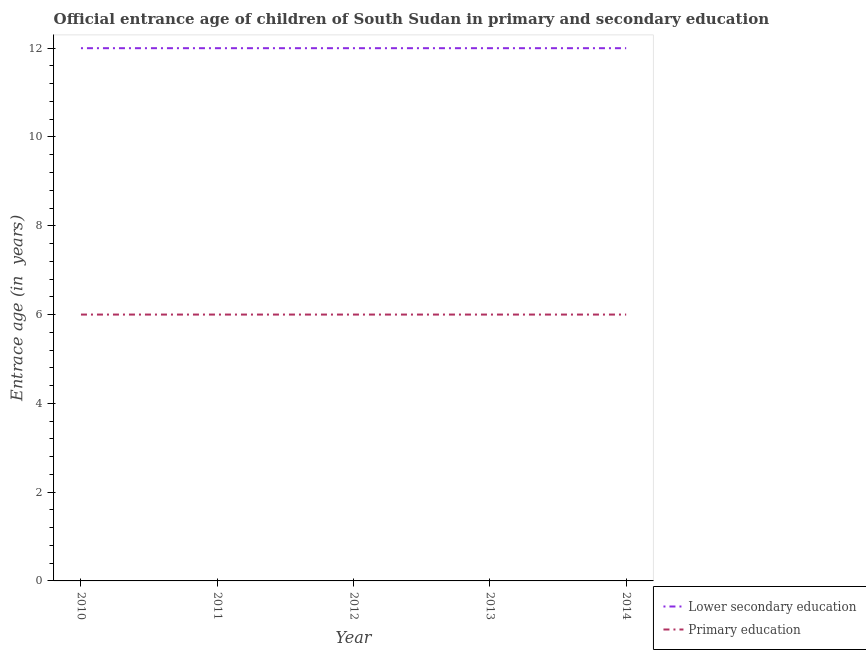Does the line corresponding to entrance age of children in lower secondary education intersect with the line corresponding to entrance age of chiildren in primary education?
Keep it short and to the point. No. Is the number of lines equal to the number of legend labels?
Offer a very short reply. Yes. What is the entrance age of chiildren in primary education in 2014?
Provide a short and direct response. 6. In which year was the entrance age of chiildren in primary education maximum?
Provide a short and direct response. 2010. What is the total entrance age of children in lower secondary education in the graph?
Keep it short and to the point. 60. What is the average entrance age of chiildren in primary education per year?
Keep it short and to the point. 6. In the year 2013, what is the difference between the entrance age of chiildren in primary education and entrance age of children in lower secondary education?
Give a very brief answer. -6. What is the ratio of the entrance age of children in lower secondary education in 2012 to that in 2013?
Offer a terse response. 1. Is the difference between the entrance age of chiildren in primary education in 2011 and 2013 greater than the difference between the entrance age of children in lower secondary education in 2011 and 2013?
Offer a very short reply. No. What is the difference between the highest and the second highest entrance age of chiildren in primary education?
Your answer should be compact. 0. In how many years, is the entrance age of children in lower secondary education greater than the average entrance age of children in lower secondary education taken over all years?
Provide a short and direct response. 0. Is the sum of the entrance age of chiildren in primary education in 2011 and 2012 greater than the maximum entrance age of children in lower secondary education across all years?
Your response must be concise. No. Does the entrance age of children in lower secondary education monotonically increase over the years?
Provide a succinct answer. No. Is the entrance age of chiildren in primary education strictly less than the entrance age of children in lower secondary education over the years?
Ensure brevity in your answer.  Yes. How many years are there in the graph?
Provide a short and direct response. 5. Are the values on the major ticks of Y-axis written in scientific E-notation?
Make the answer very short. No. Does the graph contain grids?
Your response must be concise. No. How many legend labels are there?
Keep it short and to the point. 2. How are the legend labels stacked?
Offer a terse response. Vertical. What is the title of the graph?
Your answer should be compact. Official entrance age of children of South Sudan in primary and secondary education. What is the label or title of the Y-axis?
Ensure brevity in your answer.  Entrace age (in  years). What is the Entrace age (in  years) in Lower secondary education in 2010?
Make the answer very short. 12. What is the Entrace age (in  years) in Primary education in 2010?
Your answer should be very brief. 6. What is the Entrace age (in  years) of Primary education in 2011?
Your answer should be very brief. 6. What is the Entrace age (in  years) of Lower secondary education in 2012?
Offer a very short reply. 12. What is the Entrace age (in  years) in Primary education in 2013?
Make the answer very short. 6. What is the Entrace age (in  years) in Lower secondary education in 2014?
Keep it short and to the point. 12. What is the Entrace age (in  years) in Primary education in 2014?
Your answer should be compact. 6. Across all years, what is the maximum Entrace age (in  years) in Lower secondary education?
Give a very brief answer. 12. Across all years, what is the minimum Entrace age (in  years) in Primary education?
Offer a terse response. 6. What is the total Entrace age (in  years) in Primary education in the graph?
Your answer should be compact. 30. What is the difference between the Entrace age (in  years) of Lower secondary education in 2010 and that in 2012?
Provide a succinct answer. 0. What is the difference between the Entrace age (in  years) of Primary education in 2010 and that in 2012?
Make the answer very short. 0. What is the difference between the Entrace age (in  years) in Lower secondary education in 2010 and that in 2013?
Give a very brief answer. 0. What is the difference between the Entrace age (in  years) of Primary education in 2010 and that in 2013?
Give a very brief answer. 0. What is the difference between the Entrace age (in  years) in Lower secondary education in 2010 and that in 2014?
Give a very brief answer. 0. What is the difference between the Entrace age (in  years) of Lower secondary education in 2011 and that in 2014?
Your answer should be compact. 0. What is the difference between the Entrace age (in  years) of Primary education in 2012 and that in 2013?
Offer a terse response. 0. What is the difference between the Entrace age (in  years) in Lower secondary education in 2013 and that in 2014?
Give a very brief answer. 0. What is the difference between the Entrace age (in  years) of Primary education in 2013 and that in 2014?
Offer a terse response. 0. What is the difference between the Entrace age (in  years) in Lower secondary education in 2010 and the Entrace age (in  years) in Primary education in 2012?
Your response must be concise. 6. What is the difference between the Entrace age (in  years) of Lower secondary education in 2010 and the Entrace age (in  years) of Primary education in 2014?
Offer a very short reply. 6. What is the difference between the Entrace age (in  years) in Lower secondary education in 2011 and the Entrace age (in  years) in Primary education in 2012?
Your response must be concise. 6. What is the difference between the Entrace age (in  years) of Lower secondary education in 2011 and the Entrace age (in  years) of Primary education in 2014?
Ensure brevity in your answer.  6. What is the difference between the Entrace age (in  years) in Lower secondary education in 2012 and the Entrace age (in  years) in Primary education in 2013?
Provide a short and direct response. 6. What is the difference between the Entrace age (in  years) in Lower secondary education in 2012 and the Entrace age (in  years) in Primary education in 2014?
Give a very brief answer. 6. What is the difference between the Entrace age (in  years) of Lower secondary education in 2013 and the Entrace age (in  years) of Primary education in 2014?
Keep it short and to the point. 6. What is the average Entrace age (in  years) in Lower secondary education per year?
Provide a short and direct response. 12. What is the average Entrace age (in  years) in Primary education per year?
Your answer should be compact. 6. In the year 2010, what is the difference between the Entrace age (in  years) in Lower secondary education and Entrace age (in  years) in Primary education?
Provide a succinct answer. 6. In the year 2012, what is the difference between the Entrace age (in  years) in Lower secondary education and Entrace age (in  years) in Primary education?
Ensure brevity in your answer.  6. In the year 2014, what is the difference between the Entrace age (in  years) of Lower secondary education and Entrace age (in  years) of Primary education?
Give a very brief answer. 6. What is the ratio of the Entrace age (in  years) of Lower secondary education in 2010 to that in 2011?
Offer a very short reply. 1. What is the ratio of the Entrace age (in  years) in Lower secondary education in 2010 to that in 2013?
Offer a terse response. 1. What is the ratio of the Entrace age (in  years) in Lower secondary education in 2010 to that in 2014?
Your response must be concise. 1. What is the ratio of the Entrace age (in  years) of Primary education in 2010 to that in 2014?
Ensure brevity in your answer.  1. What is the ratio of the Entrace age (in  years) in Lower secondary education in 2011 to that in 2012?
Give a very brief answer. 1. What is the ratio of the Entrace age (in  years) in Lower secondary education in 2011 to that in 2013?
Your answer should be very brief. 1. What is the ratio of the Entrace age (in  years) in Primary education in 2011 to that in 2013?
Give a very brief answer. 1. What is the ratio of the Entrace age (in  years) in Lower secondary education in 2011 to that in 2014?
Your response must be concise. 1. What is the ratio of the Entrace age (in  years) of Lower secondary education in 2012 to that in 2013?
Your response must be concise. 1. What is the ratio of the Entrace age (in  years) in Primary education in 2012 to that in 2013?
Provide a succinct answer. 1. What is the ratio of the Entrace age (in  years) in Lower secondary education in 2012 to that in 2014?
Your response must be concise. 1. What is the ratio of the Entrace age (in  years) in Lower secondary education in 2013 to that in 2014?
Your answer should be very brief. 1. What is the difference between the highest and the lowest Entrace age (in  years) of Primary education?
Provide a short and direct response. 0. 